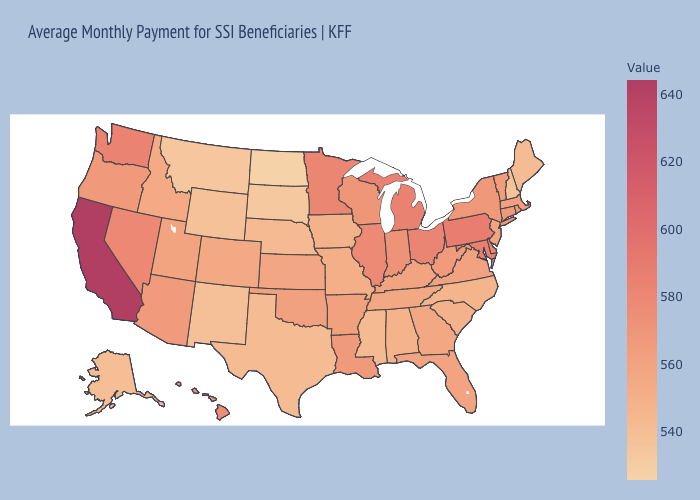Does Iowa have the lowest value in the MidWest?
Short answer required. No. Does Texas have the highest value in the South?
Give a very brief answer. No. Which states have the lowest value in the West?
Answer briefly. Montana. Is the legend a continuous bar?
Give a very brief answer. Yes. Does California have the highest value in the USA?
Short answer required. Yes. Does Mississippi have the lowest value in the USA?
Answer briefly. No. 